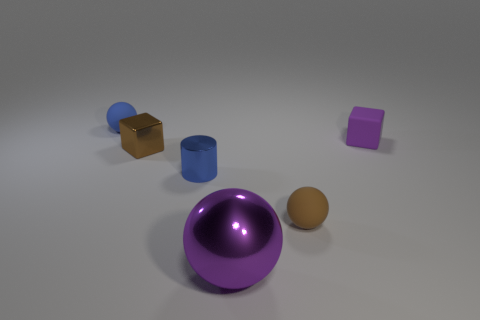Are there any other things that are the same shape as the blue shiny thing?
Provide a short and direct response. No. What is the size of the purple metal thing?
Provide a short and direct response. Large. Is the color of the small object behind the tiny purple rubber thing the same as the metal cylinder?
Give a very brief answer. Yes. What number of other things are the same size as the metallic ball?
Provide a succinct answer. 0. Is the cylinder made of the same material as the brown sphere?
Give a very brief answer. No. What is the color of the tiny rubber thing that is in front of the blue thing in front of the tiny blue rubber sphere?
Ensure brevity in your answer.  Brown. The shiny thing that is the same shape as the small brown matte thing is what size?
Make the answer very short. Large. Do the tiny rubber block and the shiny ball have the same color?
Your response must be concise. Yes. How many tiny brown metal cubes are behind the rubber block that is on the right side of the matte object in front of the blue shiny cylinder?
Your answer should be very brief. 0. Is the number of purple rubber blocks greater than the number of rubber spheres?
Keep it short and to the point. No. 